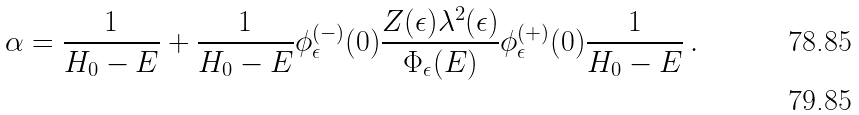<formula> <loc_0><loc_0><loc_500><loc_500>\alpha = \frac { 1 } { H _ { 0 } - E } + \frac { 1 } { H _ { 0 } - E } \phi _ { \epsilon } ^ { ( - ) } ( 0 ) \frac { Z ( \epsilon ) \lambda ^ { 2 } ( \epsilon ) } { \Phi _ { \epsilon } ( E ) } \phi _ { \epsilon } ^ { ( + ) } ( 0 ) \frac { 1 } { H _ { 0 } - E } \, . \\</formula> 